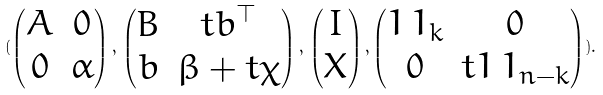Convert formula to latex. <formula><loc_0><loc_0><loc_500><loc_500>( \begin{pmatrix} A & 0 \\ 0 & \alpha \end{pmatrix} , \, \begin{pmatrix} B & t b ^ { \top } \\ b & \beta + t \chi \end{pmatrix} , \, \begin{pmatrix} I \\ X \end{pmatrix} , \begin{pmatrix} 1 \, 1 _ { k } & 0 \\ 0 & t 1 \, 1 _ { n - k } \end{pmatrix} ) .</formula> 